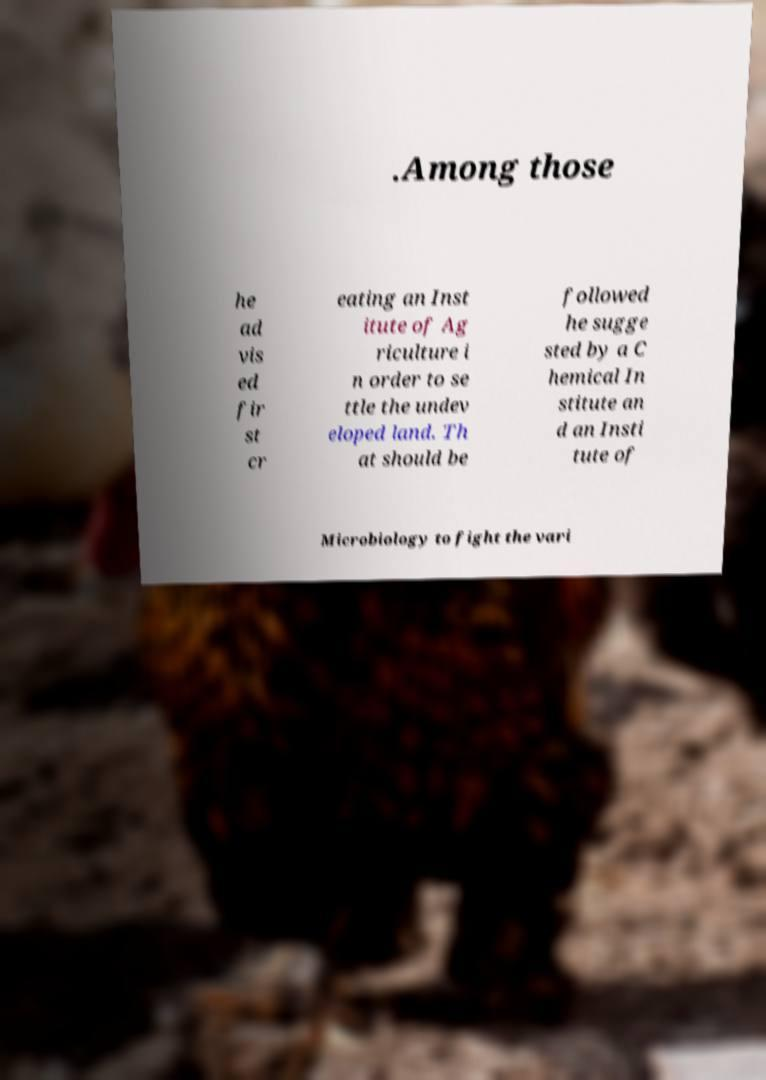For documentation purposes, I need the text within this image transcribed. Could you provide that? .Among those he ad vis ed fir st cr eating an Inst itute of Ag riculture i n order to se ttle the undev eloped land. Th at should be followed he sugge sted by a C hemical In stitute an d an Insti tute of Microbiology to fight the vari 